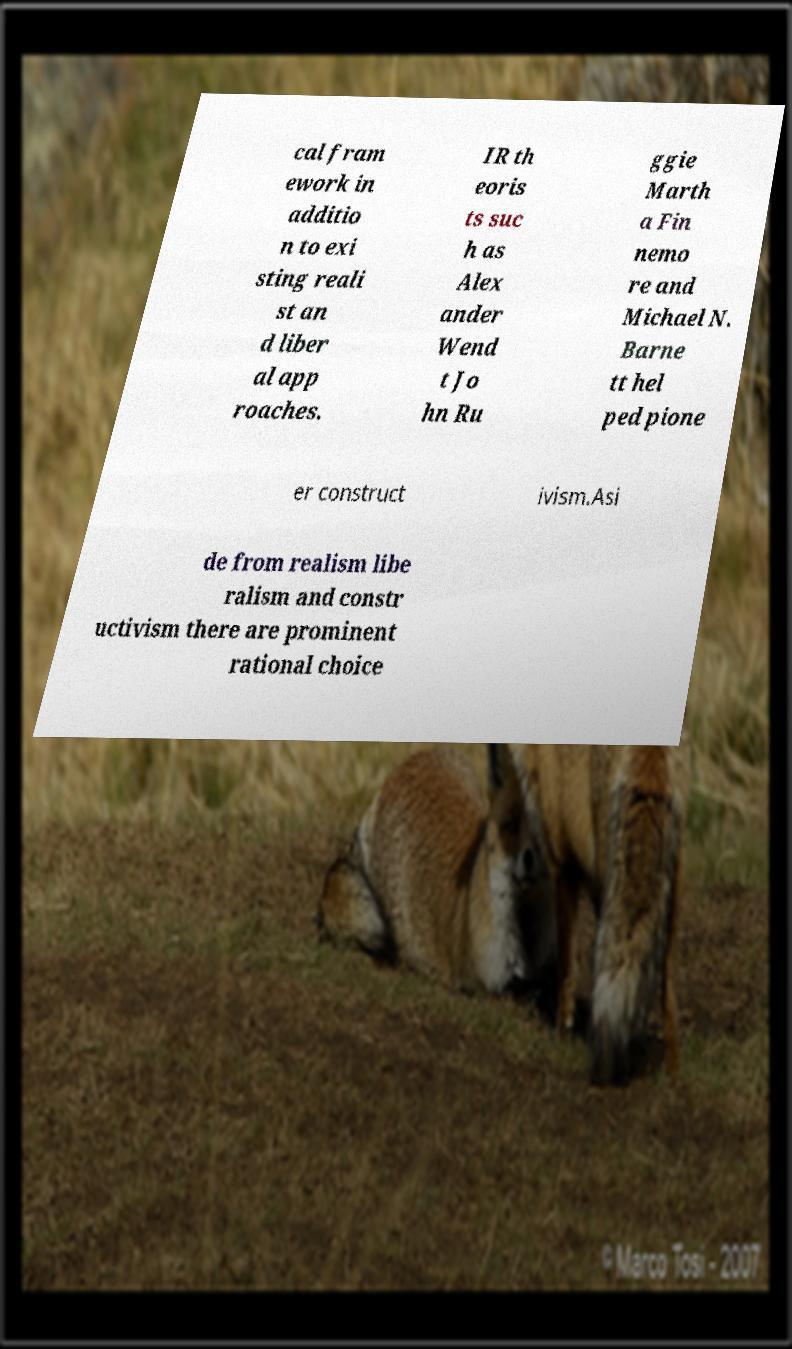What messages or text are displayed in this image? I need them in a readable, typed format. cal fram ework in additio n to exi sting reali st an d liber al app roaches. IR th eoris ts suc h as Alex ander Wend t Jo hn Ru ggie Marth a Fin nemo re and Michael N. Barne tt hel ped pione er construct ivism.Asi de from realism libe ralism and constr uctivism there are prominent rational choice 